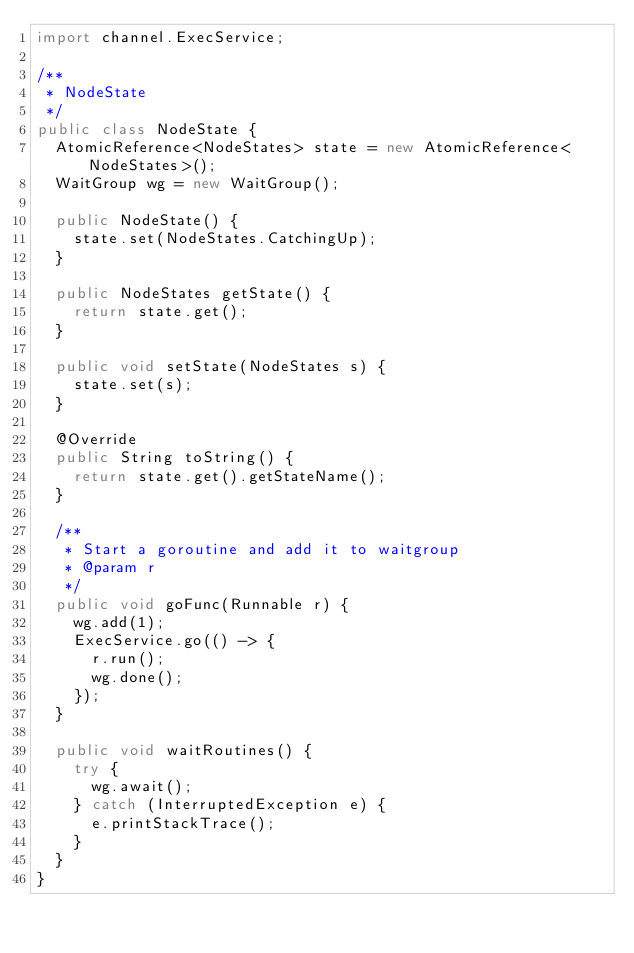<code> <loc_0><loc_0><loc_500><loc_500><_Java_>import channel.ExecService;

/**
 * NodeState
 */
public class NodeState {
	AtomicReference<NodeStates> state = new AtomicReference<NodeStates>();
	WaitGroup wg = new WaitGroup();

	public NodeState() {
		state.set(NodeStates.CatchingUp);
	}

	public NodeStates getState() {
		return state.get();
	}

	public void setState(NodeStates s) {
		state.set(s);
	}

	@Override
	public String toString() {
		return state.get().getStateName();
	}

	/**
	 * Start a goroutine and add it to waitgroup
	 * @param r
	 */
	public void goFunc(Runnable r) {
		wg.add(1);
		ExecService.go(() -> {
			r.run();
			wg.done();
		});
	}

	public void waitRoutines() {
		try {
			wg.await();
		} catch (InterruptedException e) {
			e.printStackTrace();
		}
	}
}</code> 